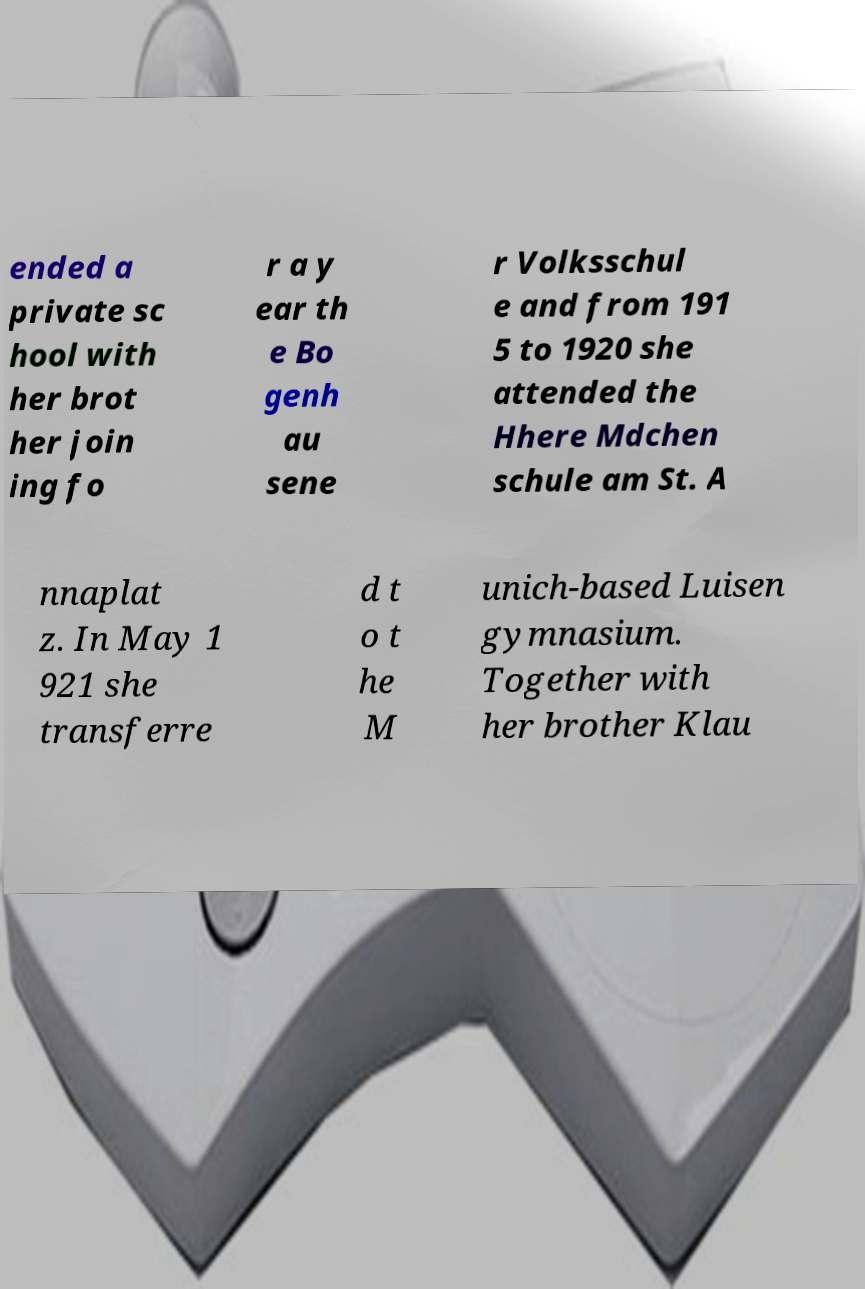Could you extract and type out the text from this image? ended a private sc hool with her brot her join ing fo r a y ear th e Bo genh au sene r Volksschul e and from 191 5 to 1920 she attended the Hhere Mdchen schule am St. A nnaplat z. In May 1 921 she transferre d t o t he M unich-based Luisen gymnasium. Together with her brother Klau 